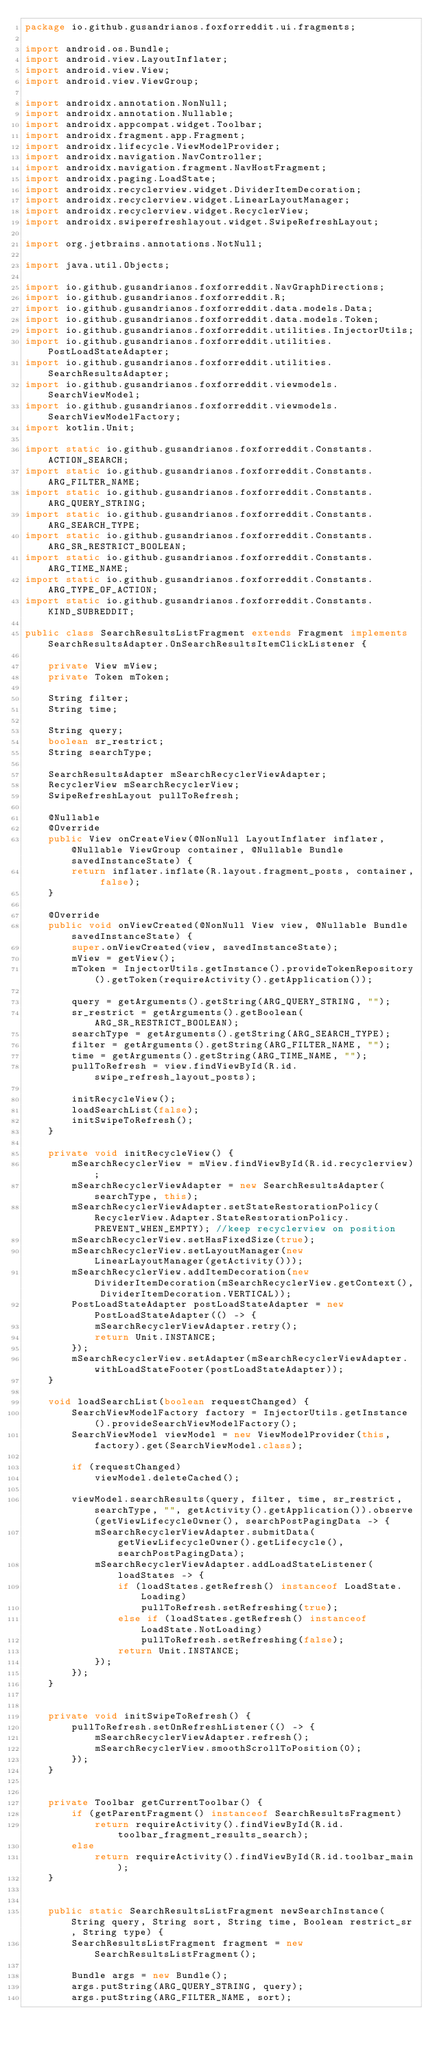<code> <loc_0><loc_0><loc_500><loc_500><_Java_>package io.github.gusandrianos.foxforreddit.ui.fragments;

import android.os.Bundle;
import android.view.LayoutInflater;
import android.view.View;
import android.view.ViewGroup;

import androidx.annotation.NonNull;
import androidx.annotation.Nullable;
import androidx.appcompat.widget.Toolbar;
import androidx.fragment.app.Fragment;
import androidx.lifecycle.ViewModelProvider;
import androidx.navigation.NavController;
import androidx.navigation.fragment.NavHostFragment;
import androidx.paging.LoadState;
import androidx.recyclerview.widget.DividerItemDecoration;
import androidx.recyclerview.widget.LinearLayoutManager;
import androidx.recyclerview.widget.RecyclerView;
import androidx.swiperefreshlayout.widget.SwipeRefreshLayout;

import org.jetbrains.annotations.NotNull;

import java.util.Objects;

import io.github.gusandrianos.foxforreddit.NavGraphDirections;
import io.github.gusandrianos.foxforreddit.R;
import io.github.gusandrianos.foxforreddit.data.models.Data;
import io.github.gusandrianos.foxforreddit.data.models.Token;
import io.github.gusandrianos.foxforreddit.utilities.InjectorUtils;
import io.github.gusandrianos.foxforreddit.utilities.PostLoadStateAdapter;
import io.github.gusandrianos.foxforreddit.utilities.SearchResultsAdapter;
import io.github.gusandrianos.foxforreddit.viewmodels.SearchViewModel;
import io.github.gusandrianos.foxforreddit.viewmodels.SearchViewModelFactory;
import kotlin.Unit;

import static io.github.gusandrianos.foxforreddit.Constants.ACTION_SEARCH;
import static io.github.gusandrianos.foxforreddit.Constants.ARG_FILTER_NAME;
import static io.github.gusandrianos.foxforreddit.Constants.ARG_QUERY_STRING;
import static io.github.gusandrianos.foxforreddit.Constants.ARG_SEARCH_TYPE;
import static io.github.gusandrianos.foxforreddit.Constants.ARG_SR_RESTRICT_BOOLEAN;
import static io.github.gusandrianos.foxforreddit.Constants.ARG_TIME_NAME;
import static io.github.gusandrianos.foxforreddit.Constants.ARG_TYPE_OF_ACTION;
import static io.github.gusandrianos.foxforreddit.Constants.KIND_SUBREDDIT;

public class SearchResultsListFragment extends Fragment implements SearchResultsAdapter.OnSearchResultsItemClickListener {

    private View mView;
    private Token mToken;

    String filter;
    String time;

    String query;
    boolean sr_restrict;
    String searchType;

    SearchResultsAdapter mSearchRecyclerViewAdapter;
    RecyclerView mSearchRecyclerView;
    SwipeRefreshLayout pullToRefresh;

    @Nullable
    @Override
    public View onCreateView(@NonNull LayoutInflater inflater, @Nullable ViewGroup container, @Nullable Bundle savedInstanceState) {
        return inflater.inflate(R.layout.fragment_posts, container, false);
    }

    @Override
    public void onViewCreated(@NonNull View view, @Nullable Bundle savedInstanceState) {
        super.onViewCreated(view, savedInstanceState);
        mView = getView();
        mToken = InjectorUtils.getInstance().provideTokenRepository().getToken(requireActivity().getApplication());

        query = getArguments().getString(ARG_QUERY_STRING, "");
        sr_restrict = getArguments().getBoolean(ARG_SR_RESTRICT_BOOLEAN);
        searchType = getArguments().getString(ARG_SEARCH_TYPE);
        filter = getArguments().getString(ARG_FILTER_NAME, "");
        time = getArguments().getString(ARG_TIME_NAME, "");
        pullToRefresh = view.findViewById(R.id.swipe_refresh_layout_posts);

        initRecycleView();
        loadSearchList(false);
        initSwipeToRefresh();
    }

    private void initRecycleView() {
        mSearchRecyclerView = mView.findViewById(R.id.recyclerview);
        mSearchRecyclerViewAdapter = new SearchResultsAdapter(searchType, this);
        mSearchRecyclerViewAdapter.setStateRestorationPolicy(RecyclerView.Adapter.StateRestorationPolicy.PREVENT_WHEN_EMPTY); //keep recyclerview on position
        mSearchRecyclerView.setHasFixedSize(true);
        mSearchRecyclerView.setLayoutManager(new LinearLayoutManager(getActivity()));
        mSearchRecyclerView.addItemDecoration(new DividerItemDecoration(mSearchRecyclerView.getContext(), DividerItemDecoration.VERTICAL));
        PostLoadStateAdapter postLoadStateAdapter = new PostLoadStateAdapter(() -> {
            mSearchRecyclerViewAdapter.retry();
            return Unit.INSTANCE;
        });
        mSearchRecyclerView.setAdapter(mSearchRecyclerViewAdapter.withLoadStateFooter(postLoadStateAdapter));
    }

    void loadSearchList(boolean requestChanged) {
        SearchViewModelFactory factory = InjectorUtils.getInstance().provideSearchViewModelFactory();
        SearchViewModel viewModel = new ViewModelProvider(this, factory).get(SearchViewModel.class);

        if (requestChanged)
            viewModel.deleteCached();

        viewModel.searchResults(query, filter, time, sr_restrict, searchType, "", getActivity().getApplication()).observe(getViewLifecycleOwner(), searchPostPagingData -> {
            mSearchRecyclerViewAdapter.submitData(getViewLifecycleOwner().getLifecycle(), searchPostPagingData);
            mSearchRecyclerViewAdapter.addLoadStateListener(loadStates -> {
                if (loadStates.getRefresh() instanceof LoadState.Loading)
                    pullToRefresh.setRefreshing(true);
                else if (loadStates.getRefresh() instanceof LoadState.NotLoading)
                    pullToRefresh.setRefreshing(false);
                return Unit.INSTANCE;
            });
        });
    }


    private void initSwipeToRefresh() {
        pullToRefresh.setOnRefreshListener(() -> {
            mSearchRecyclerViewAdapter.refresh();
            mSearchRecyclerView.smoothScrollToPosition(0);
        });
    }


    private Toolbar getCurrentToolbar() {
        if (getParentFragment() instanceof SearchResultsFragment)
            return requireActivity().findViewById(R.id.toolbar_fragment_results_search);
        else
            return requireActivity().findViewById(R.id.toolbar_main);
    }


    public static SearchResultsListFragment newSearchInstance(String query, String sort, String time, Boolean restrict_sr, String type) {
        SearchResultsListFragment fragment = new SearchResultsListFragment();

        Bundle args = new Bundle();
        args.putString(ARG_QUERY_STRING, query);
        args.putString(ARG_FILTER_NAME, sort);</code> 